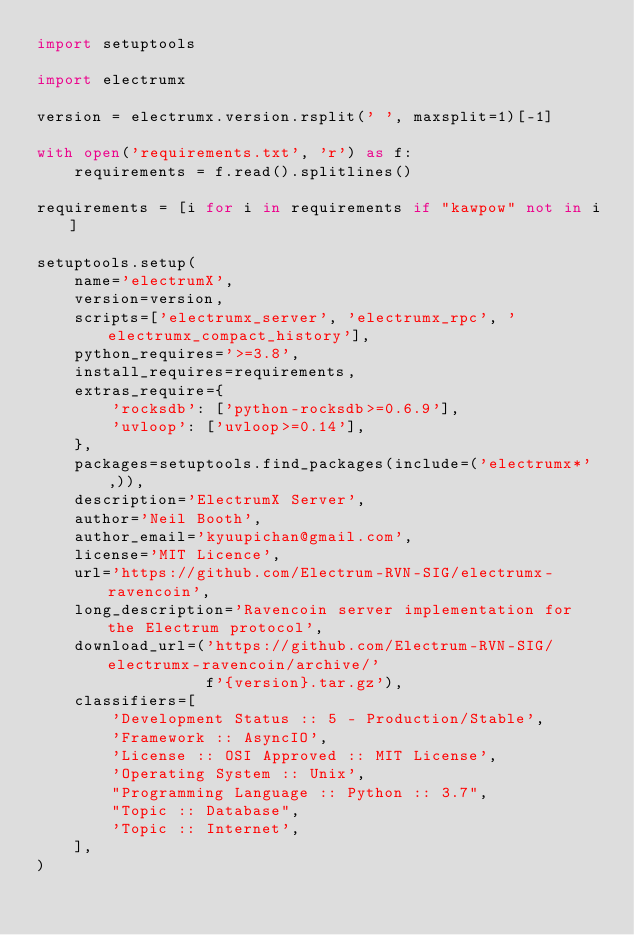<code> <loc_0><loc_0><loc_500><loc_500><_Python_>import setuptools

import electrumx

version = electrumx.version.rsplit(' ', maxsplit=1)[-1]

with open('requirements.txt', 'r') as f:
    requirements = f.read().splitlines()

requirements = [i for i in requirements if "kawpow" not in i]

setuptools.setup(
    name='electrumX',
    version=version,
    scripts=['electrumx_server', 'electrumx_rpc', 'electrumx_compact_history'],
    python_requires='>=3.8',
    install_requires=requirements,
    extras_require={
        'rocksdb': ['python-rocksdb>=0.6.9'],
        'uvloop': ['uvloop>=0.14'],
    },
    packages=setuptools.find_packages(include=('electrumx*',)),
    description='ElectrumX Server',
    author='Neil Booth',
    author_email='kyuupichan@gmail.com',
    license='MIT Licence',
    url='https://github.com/Electrum-RVN-SIG/electrumx-ravencoin',
    long_description='Ravencoin server implementation for the Electrum protocol',
    download_url=('https://github.com/Electrum-RVN-SIG/electrumx-ravencoin/archive/'
                  f'{version}.tar.gz'),
    classifiers=[
        'Development Status :: 5 - Production/Stable',
        'Framework :: AsyncIO',
        'License :: OSI Approved :: MIT License',
        'Operating System :: Unix',
        "Programming Language :: Python :: 3.7",
        "Topic :: Database",
        'Topic :: Internet',
    ],
)
</code> 